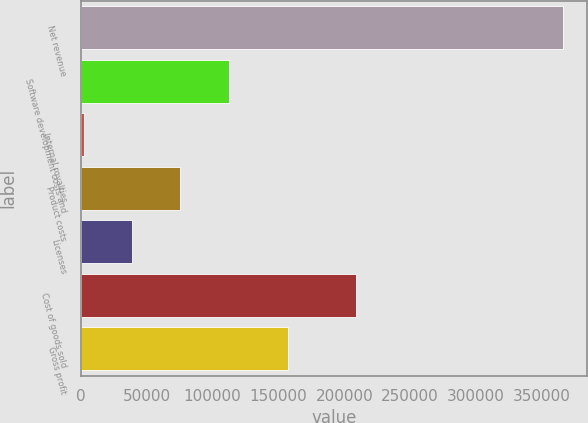Convert chart to OTSL. <chart><loc_0><loc_0><loc_500><loc_500><bar_chart><fcel>Net revenue<fcel>Software development costs and<fcel>Internal royalties<fcel>Product costs<fcel>Licenses<fcel>Cost of goods sold<fcel>Gross profit<nl><fcel>366050<fcel>112163<fcel>2172<fcel>75430.8<fcel>39043<fcel>209086<fcel>156964<nl></chart> 